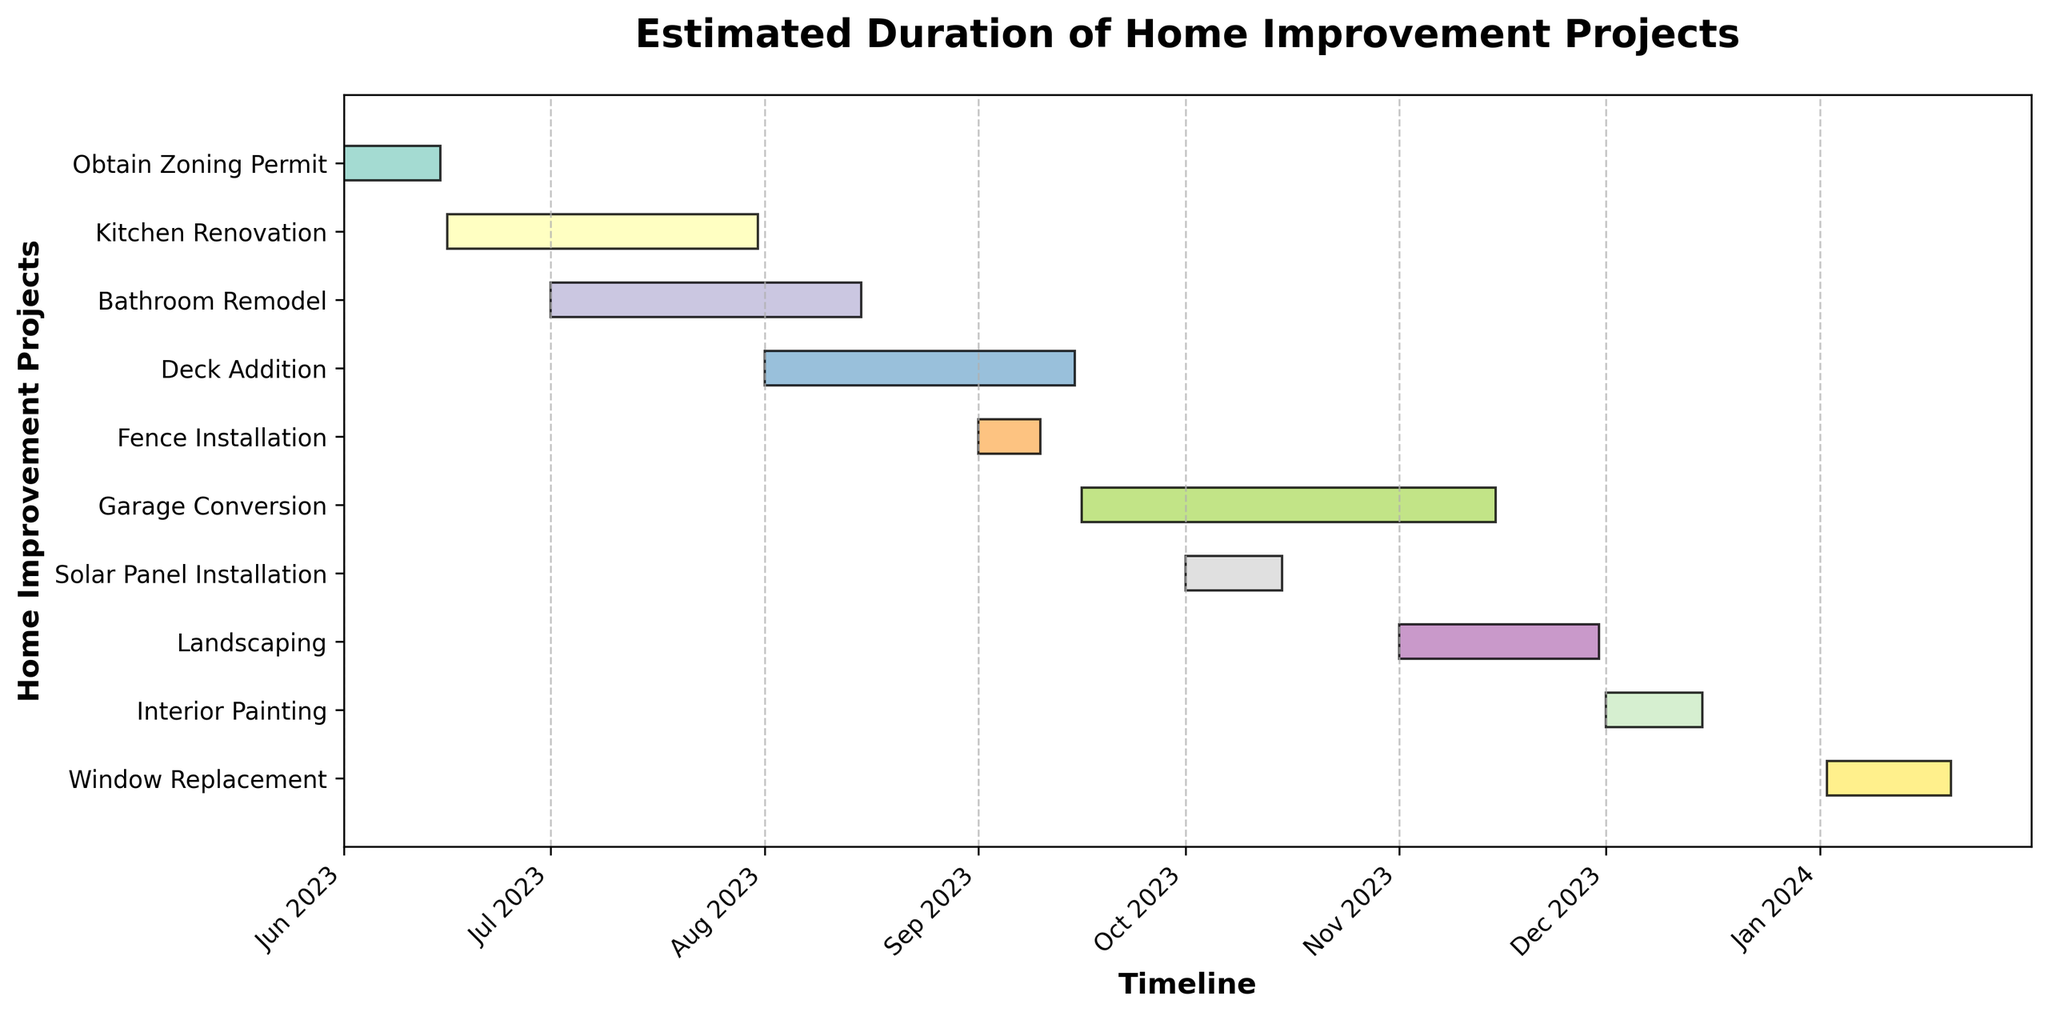Which home improvement project has the longest estimated duration? By inspecting the horizontal bars' lengths, the Garage Conversion project has the longest bar, indicating the longest duration.
Answer: Garage Conversion Which two projects overlap in the month of July 2023? Identify projects whose horizontal bars span through July 2023 by checking their start and end dates. Kitchen Renovation (June 16 to July 31) and Bathroom Remodel (July 1 to August 15) both overlap in July.
Answer: Kitchen Renovation and Bathroom Remodel How many projects start in September? Look for bars that begin within the month of September. Fence Installation (September 1-10) and Garage Conversion (September 16 to November 15) begin in September.
Answer: 2 What is the combined duration of the Kitchen Renovation and Bathroom Remodel projects? The Kitchen Renovation lasts from June 16 to July 31 (46 days), and the Bathroom Remodel lasts from July 1 to August 15 (46 days). Combined duration is 46 + 46.
Answer: 92 days Which project occurs entirely within the month of October? Identify projects whose start and end dates both fall within October. Solar Panel Installation occurs from October 1 to October 15.
Answer: Solar Panel Installation Do any projects extend into the year 2024? Look for bars that extend beyond December 2023. Window Replacement (January 2 to January 20, 2024) spans into 2024.
Answer: Yes, the Window Replacement Which project has the shortest duration? By examining the lengths of the horizontal bars, Fence Installation appears shortest, suggesting the least duration.
Answer: Fence Installation What is the total number of improvement projects listed? Count all the distinct horizontal bars representing different projects. There are 10 projects in total.
Answer: 10 Is there any project whose duration is confined within two weeks? Inspect project bars and their durations. Interior Painting runs from December 1 to December 15, lasting exactly two weeks. Fence Installation also fits with a span from September 1 to September 10, lasting 10 days.
Answer: Yes, Interior Painting and Fence Installation How many projects start in June? Locate bars beginning in June to determine the count. Only Obtain Zoning Permit (June 1 to June 15) and Kitchen Renovation (June 16 to July 31) start in June.
Answer: 2 